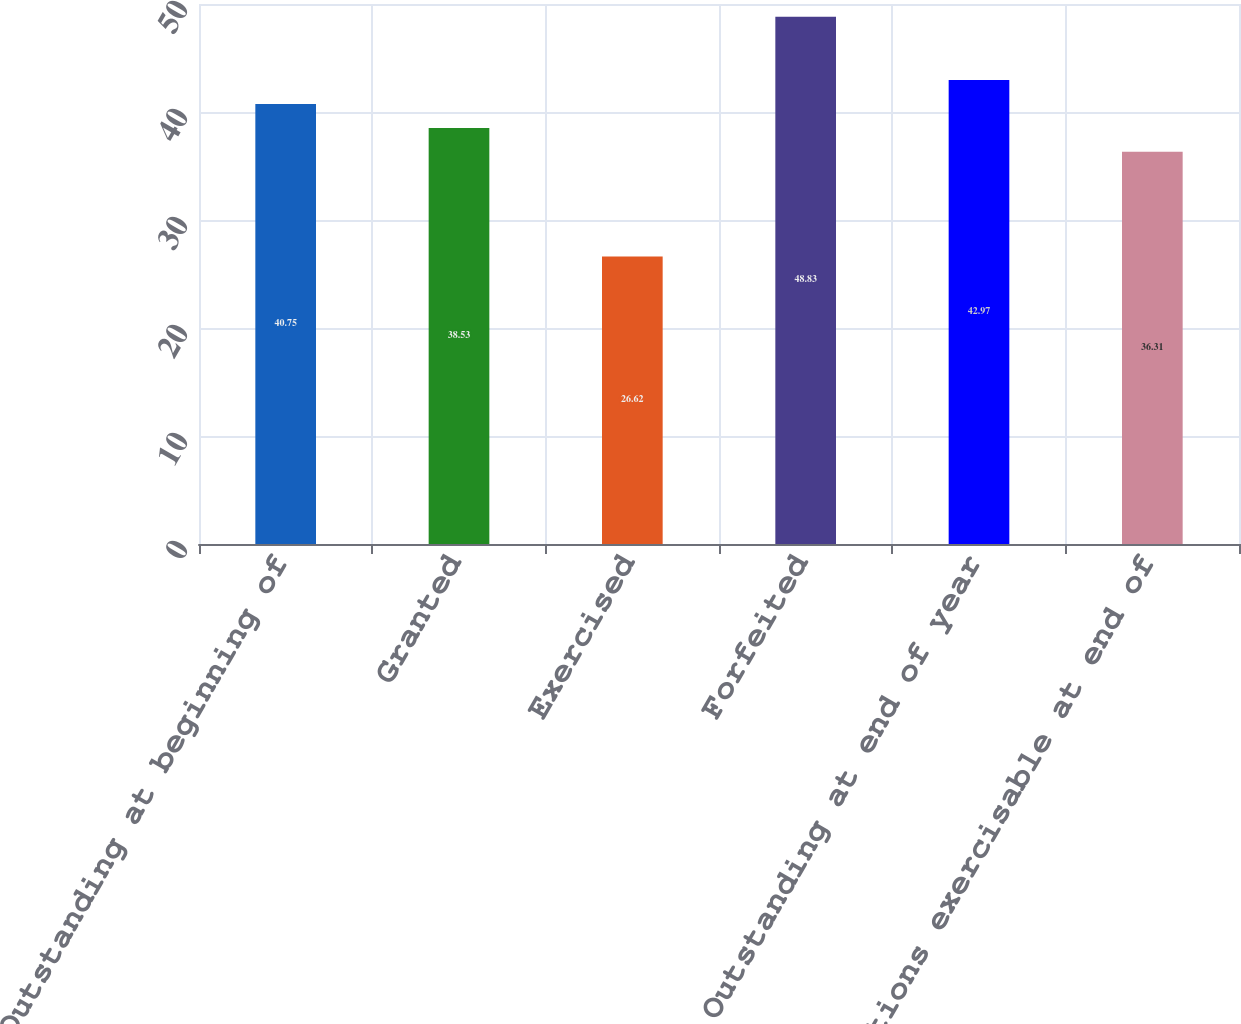<chart> <loc_0><loc_0><loc_500><loc_500><bar_chart><fcel>Outstanding at beginning of<fcel>Granted<fcel>Exercised<fcel>Forfeited<fcel>Outstanding at end of year<fcel>Options exercisable at end of<nl><fcel>40.75<fcel>38.53<fcel>26.62<fcel>48.83<fcel>42.97<fcel>36.31<nl></chart> 